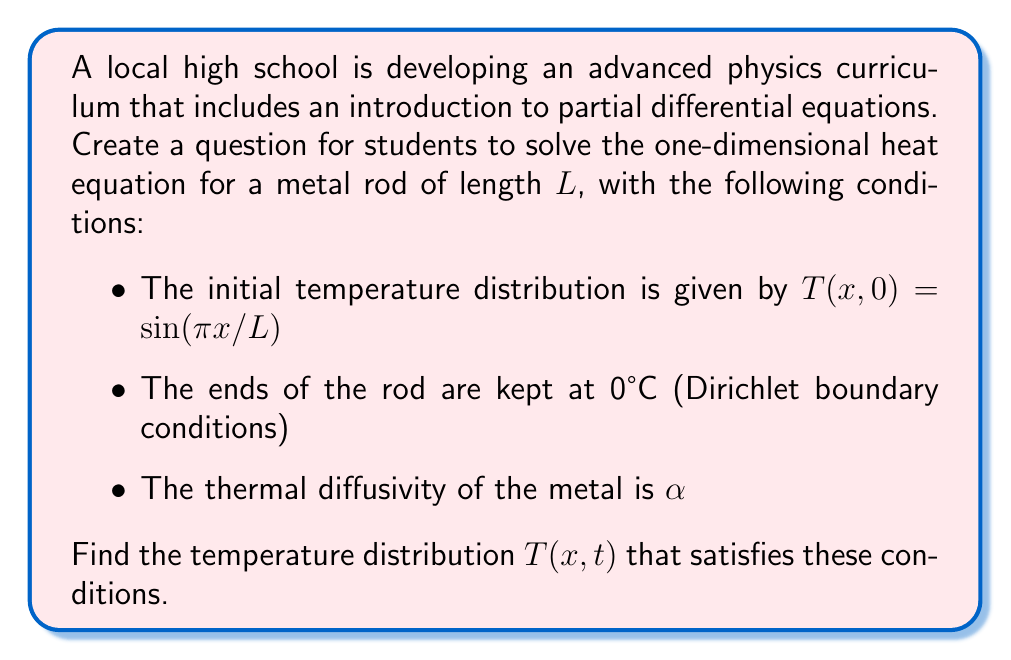Can you answer this question? To solve this problem, we'll follow these steps:

1) The one-dimensional heat equation is given by:

   $$\frac{\partial T}{\partial t} = \alpha \frac{\partial^2 T}{\partial x^2}$$

2) We need to solve this equation with the given initial and boundary conditions:

   Initial condition: $T(x,0) = \sin(\pi x/L)$
   Boundary conditions: $T(0,t) = T(L,t) = 0$

3) We can use the method of separation of variables. Let $T(x,t) = X(x)T(t)$

4) Substituting this into the heat equation:

   $$X(x)T'(t) = \alpha X''(x)T(t)$$

   $$\frac{T'(t)}{T(t)} = \alpha \frac{X''(x)}{X(x)} = -\lambda$$

   Where $\lambda$ is a constant.

5) This gives us two ordinary differential equations:

   $$T'(t) + \alpha \lambda T(t) = 0$$
   $$X''(x) + \lambda X(x) = 0$$

6) The general solution for $X(x)$ is:

   $$X(x) = A \sin(\sqrt{\lambda}x) + B \cos(\sqrt{\lambda}x)$$

7) Applying the boundary conditions:

   $X(0) = 0$ implies $B = 0$
   $X(L) = 0$ implies $\sin(\sqrt{\lambda}L) = 0$

   This means $\sqrt{\lambda}L = n\pi$, or $\lambda_n = (\frac{n\pi}{L})^2$

8) The general solution for $T(t)$ is:

   $$T(t) = Ce^{-\alpha \lambda_n t}$$

9) Therefore, the general solution is:

   $$T(x,t) = \sum_{n=1}^{\infty} C_n \sin(\frac{n\pi x}{L})e^{-\alpha (\frac{n\pi}{L})^2 t}$$

10) To satisfy the initial condition:

    $$\sin(\frac{\pi x}{L}) = \sum_{n=1}^{\infty} C_n \sin(\frac{n\pi x}{L})$$

11) This is satisfied when $n=1$ and $C_1 = 1$, with all other $C_n = 0$

Therefore, the final solution is:

$$T(x,t) = \sin(\frac{\pi x}{L})e^{-\alpha (\frac{\pi}{L})^2 t}$$
Answer: $T(x,t) = \sin(\frac{\pi x}{L})e^{-\alpha (\frac{\pi}{L})^2 t}$ 